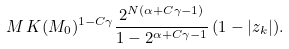Convert formula to latex. <formula><loc_0><loc_0><loc_500><loc_500>M \, K ( M _ { 0 } ) ^ { 1 - C \gamma } \frac { 2 ^ { N ( \alpha + C \gamma - 1 ) } } { 1 - 2 ^ { \alpha + C \gamma - 1 } } \, ( 1 - | z _ { k } | ) .</formula> 